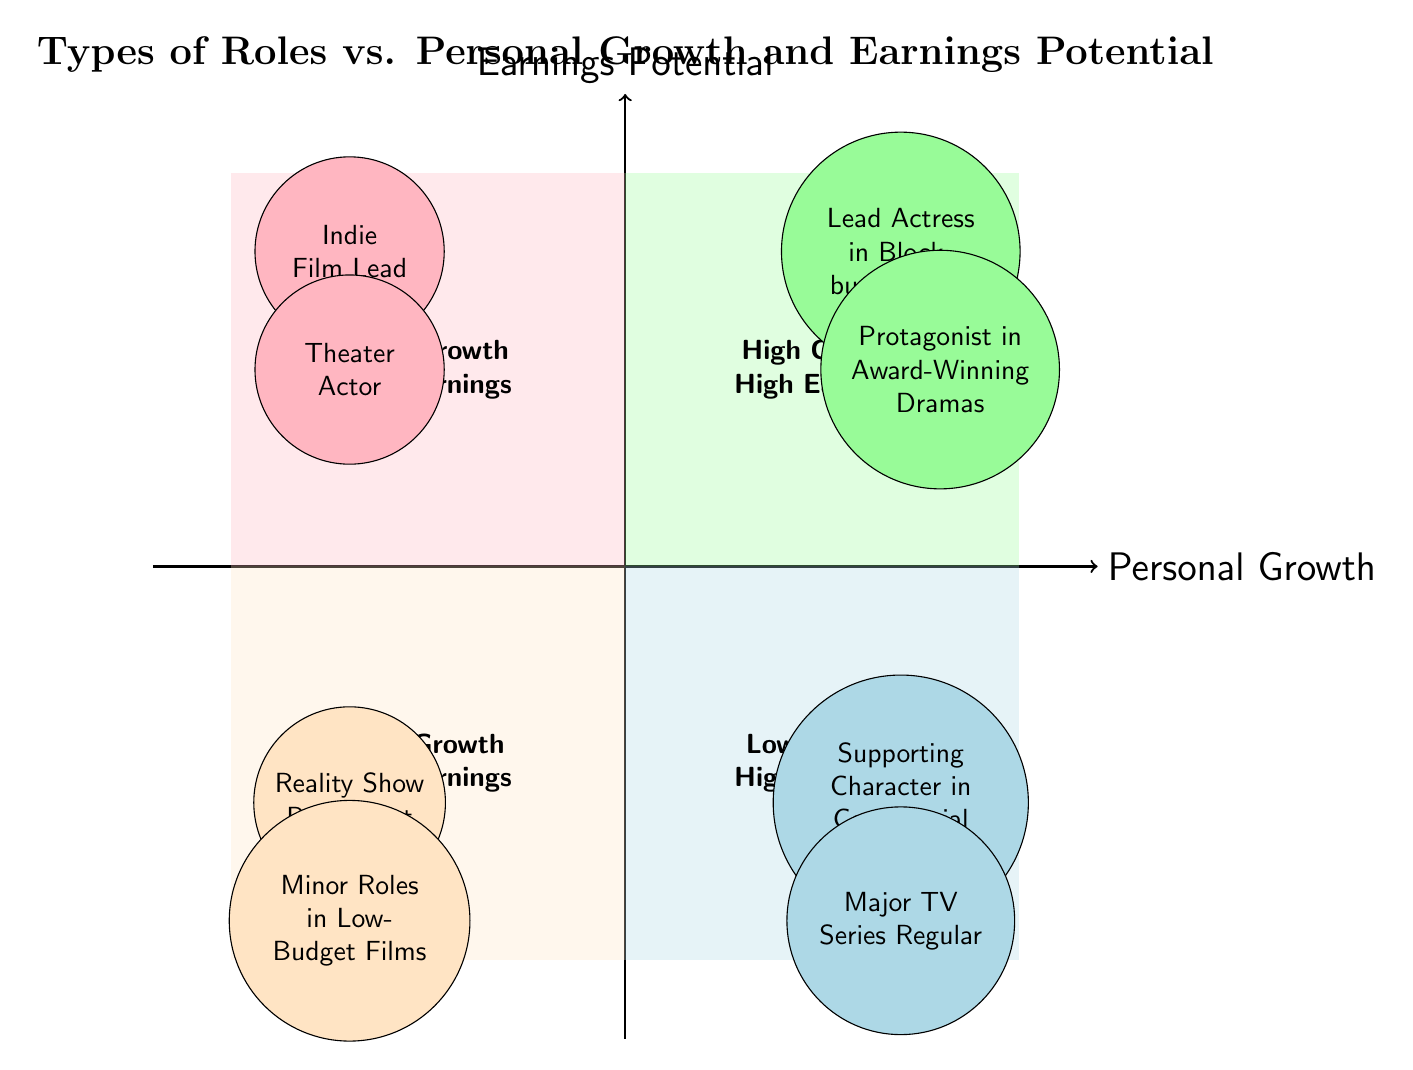What role is positioned in the "High Personal Growth and High Earnings Potential" quadrant? This role is clearly designated within the top-right quadrant of the diagram, which represents high personal growth and high earnings potential. By looking at that area, we can see that it identifies the "Lead Actress in Blockbuster Films" role prominently.
Answer: Lead Actress in Blockbuster Films How many roles are there in the "Low Personal Growth and Low Earnings Potential" quadrant? By examining the bottom-left quadrant, labeled "Low Growth Low Earnings," we count the instances to determine the total number of roles listed here. There are two specific roles mentioned within this quadrant, leading to the conclusion.
Answer: 2 Which role has high earnings potential but low personal growth? Focusing on the "Low Personal Growth and High Earnings Potential" quadrant on the bottom-right of the diagram, we look for roles listed that match these criteria. "Supporting Character in Commercial Blockbusters" meets this requirement distinctly and is noted in this area.
Answer: Supporting Character in Commercial Blockbusters What are the examples associated with the "Indie Film Lead" role? To answer this, we find the position of "Indie Film Lead" within the "High Personal Growth and Low Earnings Potential" quadrant. The examples tied to this role, as denoted in the chart, are "Lady Bird" and "Moonlight."
Answer: Lady Bird, Moonlight Which quadrant contains the role "Major TV Series Regular"? Locating "Major TV Series Regular" on the diagram, we can determine its placement by identifying the quadrant based on its characteristics. It is found in the "Low Personal Growth and High Earnings Potential" quadrant, which is in the bottom-right area of the chart.
Answer: Low Personal Growth and High Earnings Potential What characterizes the roles in the "High Personal Growth and Low Earnings Potential" quadrant? This quadrant signifies roles that promote personal growth but offer lower salary prospects. Looking at the diagram, the roles here include "Indie Film Lead" and "Theater Actor," illustrating this trait clearly.
Answer: Indie Film Lead, Theater Actor How many quadrants are there in the diagram? The diagram is structured into four distinct sections or quadrants, which categorically represent the relationships between personal growth and earnings potential. Each area depicts a specific combination of these two factors.
Answer: 4 What is the primary focus of the "Low Personal Growth and High Earnings Potential" quadrant? This quadrant highlights roles that provide substantial earnings yet lack opportunities for personal development. In this space, roles like "Supporting Character in Commercial Blockbusters" are emphasized, showcasing this focus effectively.
Answer: Commercial success without personal growth 